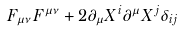Convert formula to latex. <formula><loc_0><loc_0><loc_500><loc_500>F _ { \mu \nu } F ^ { \mu \nu } + 2 \partial _ { \mu } X ^ { i } \partial ^ { \mu } X ^ { j } \delta _ { i j }</formula> 